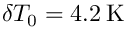<formula> <loc_0><loc_0><loc_500><loc_500>\delta T _ { 0 } = 4 . 2 \, K</formula> 